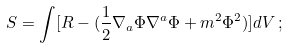<formula> <loc_0><loc_0><loc_500><loc_500>S = \int [ R - ( \frac { 1 } { 2 } \nabla _ { a } \Phi \nabla ^ { a } \Phi + m ^ { 2 } \Phi ^ { 2 } ) ] d V \, ;</formula> 